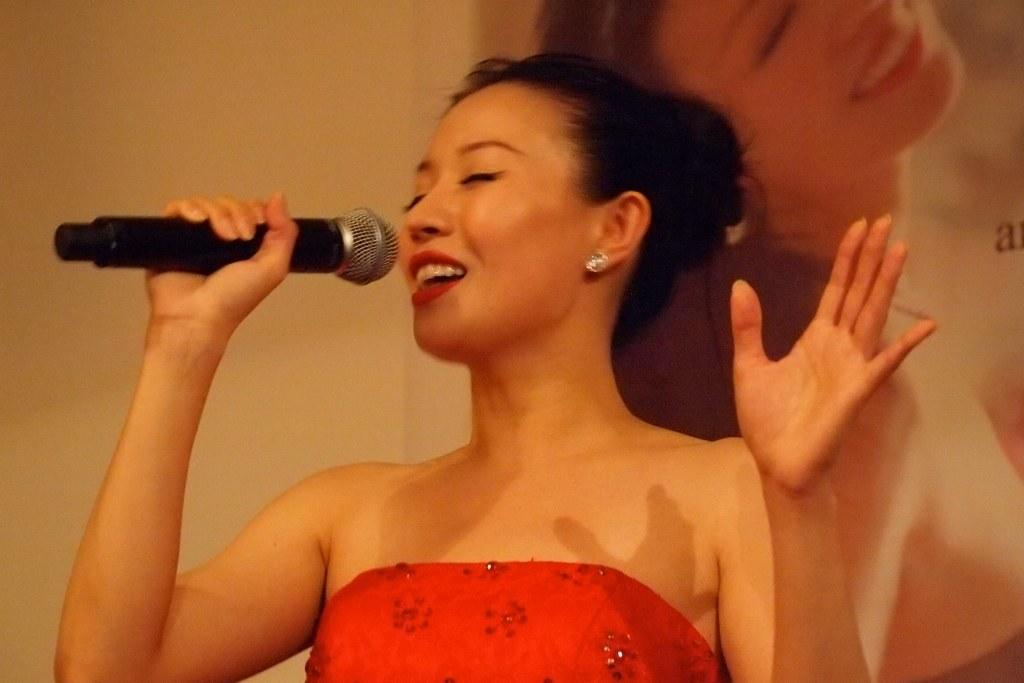Who is the main subject in the image? There is a woman in the image. What is the woman holding in the image? The woman is holding a microphone. What is the woman doing in the image? The woman is singing a song. What is the woman wearing in the image? The woman is wearing a red dress. What type of fact can be seen in the image? There is no fact present in the image; it is a picture of a woman singing with a microphone while wearing a red dress. 